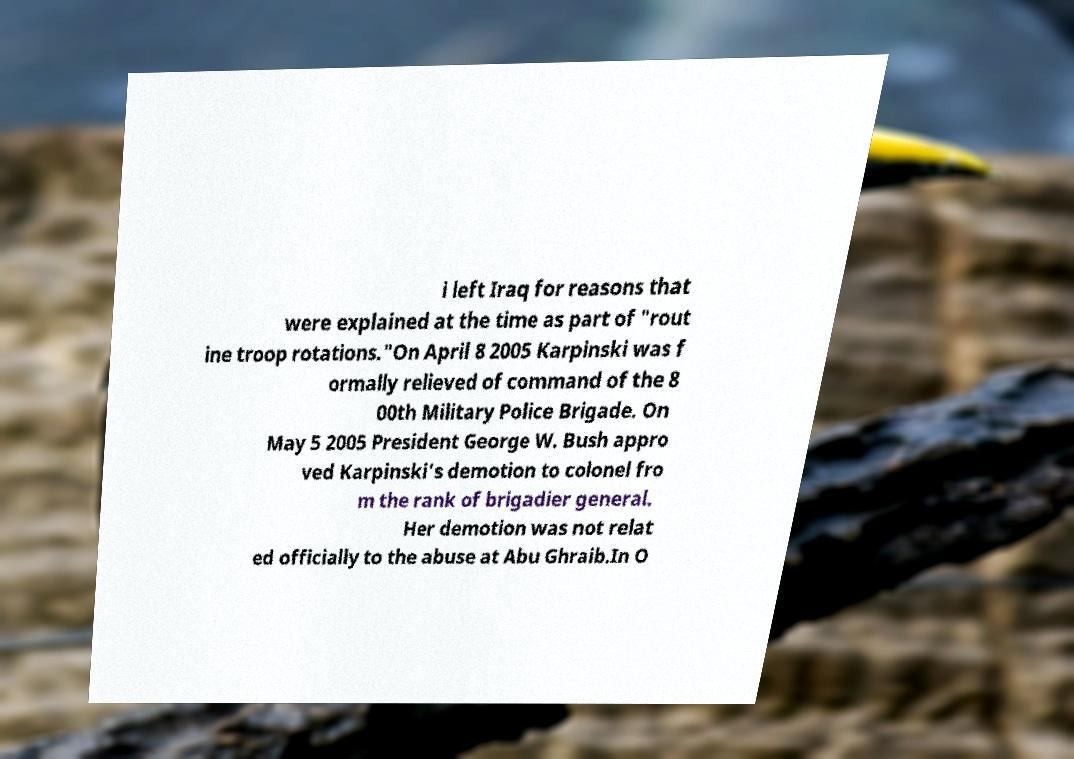I need the written content from this picture converted into text. Can you do that? i left Iraq for reasons that were explained at the time as part of "rout ine troop rotations."On April 8 2005 Karpinski was f ormally relieved of command of the 8 00th Military Police Brigade. On May 5 2005 President George W. Bush appro ved Karpinski's demotion to colonel fro m the rank of brigadier general. Her demotion was not relat ed officially to the abuse at Abu Ghraib.In O 